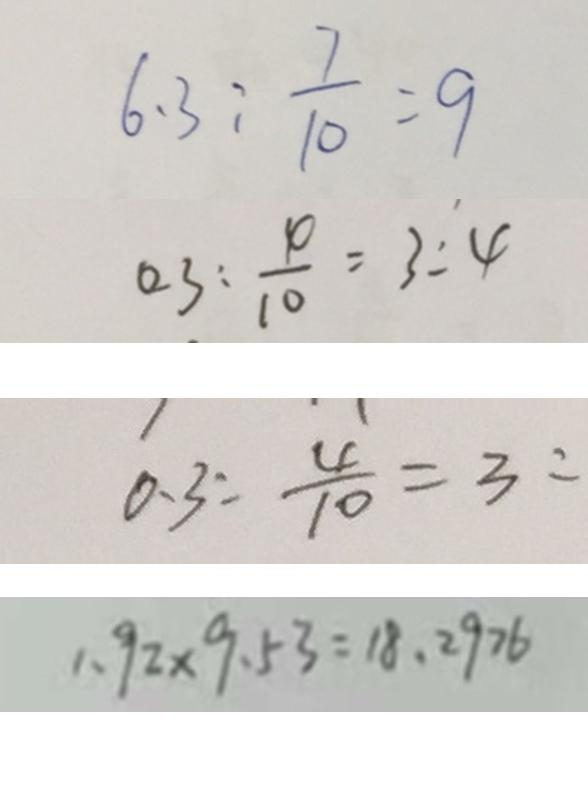<formula> <loc_0><loc_0><loc_500><loc_500>6 . 3 : \frac { 7 } { 1 0 } = 9 
 0 . 3 : \frac { \varphi } { 1 0 } = 3 : 4 
 0 . 3 : \frac { 4 } { 1 0 } = 3 : 
 1 . 9 2 \times 9 . 5 3 = 1 8 . 2 9 7 6</formula> 